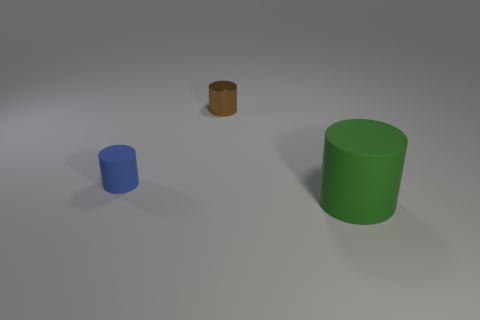Add 2 brown metallic balls. How many objects exist? 5 Subtract all green cylinders. How many cylinders are left? 2 Subtract 1 cylinders. How many cylinders are left? 2 Subtract all green cylinders. How many cylinders are left? 2 Add 2 big purple metal spheres. How many big purple metal spheres exist? 2 Subtract 0 blue blocks. How many objects are left? 3 Subtract all blue cylinders. Subtract all gray cubes. How many cylinders are left? 2 Subtract all large gray matte blocks. Subtract all brown metallic cylinders. How many objects are left? 2 Add 1 small rubber cylinders. How many small rubber cylinders are left? 2 